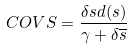Convert formula to latex. <formula><loc_0><loc_0><loc_500><loc_500>C O V S = \frac { \delta s d ( s ) } { \gamma + \delta \overline { s } }</formula> 